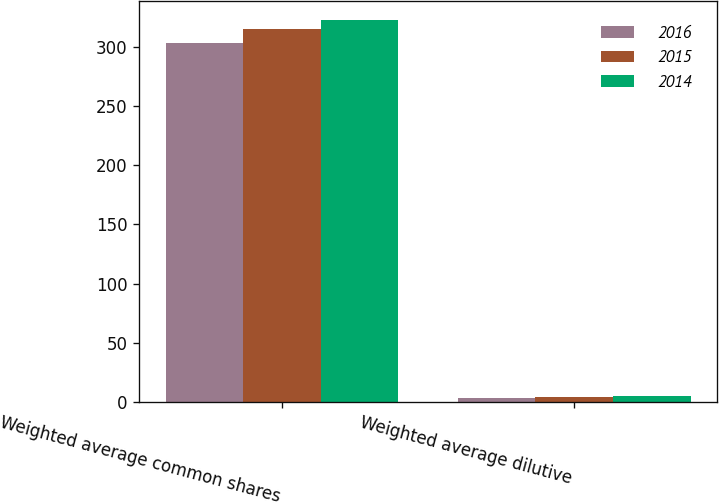Convert chart. <chart><loc_0><loc_0><loc_500><loc_500><stacked_bar_chart><ecel><fcel>Weighted average common shares<fcel>Weighted average dilutive<nl><fcel>2016<fcel>303.1<fcel>3.8<nl><fcel>2015<fcel>314.7<fcel>4.4<nl><fcel>2014<fcel>322.4<fcel>5.6<nl></chart> 